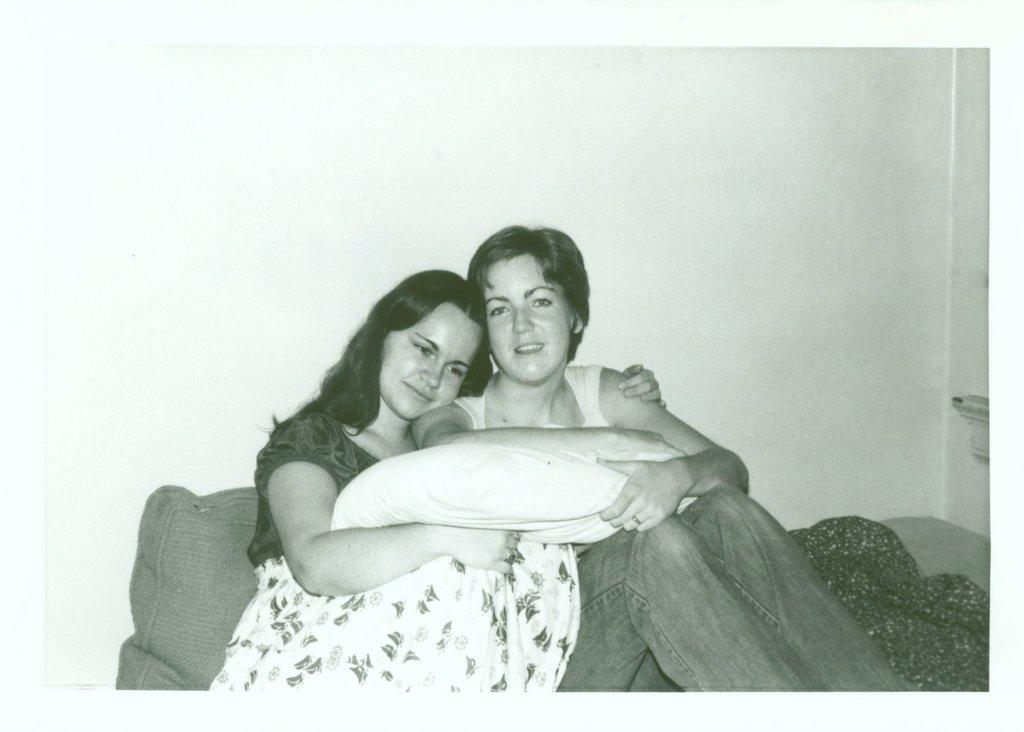How many people are in the image? There are two people in the image. What are the two people doing in the image? The two people are sitting. Where are the two people sitting in the image? They are sitting in front of a wall. What are the two people holding in the image? They are holding a pillow. What type of plane can be seen flying in the image? There is no plane visible in the image. 